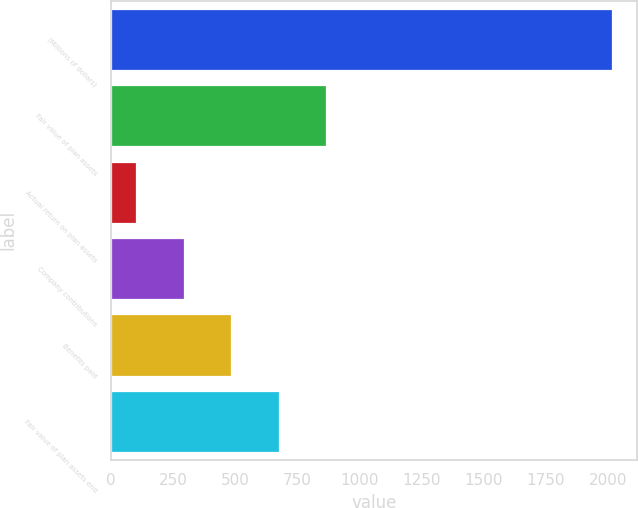Convert chart to OTSL. <chart><loc_0><loc_0><loc_500><loc_500><bar_chart><fcel>(Millions of dollars)<fcel>Fair value of plan assets<fcel>Actual return on plan assets<fcel>Company contributions<fcel>Benefits paid<fcel>Fair value of plan assets end<nl><fcel>2017<fcel>867.4<fcel>101<fcel>292.6<fcel>484.2<fcel>675.8<nl></chart> 